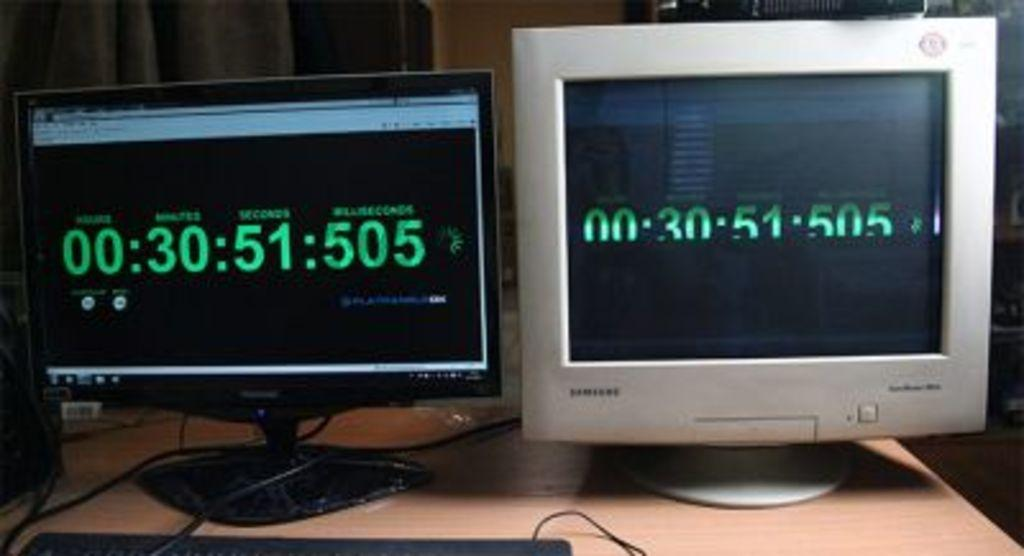Provide a one-sentence caption for the provided image. Two computer monitors side by side, one a flat panel screen, the other a CRT monitor, both showing that there are 30 minutes and 51 seconds remaining. 